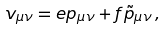<formula> <loc_0><loc_0><loc_500><loc_500>v _ { \mu \nu } = e p _ { \mu \nu } + f \tilde { p } _ { \mu \nu } \, ,</formula> 